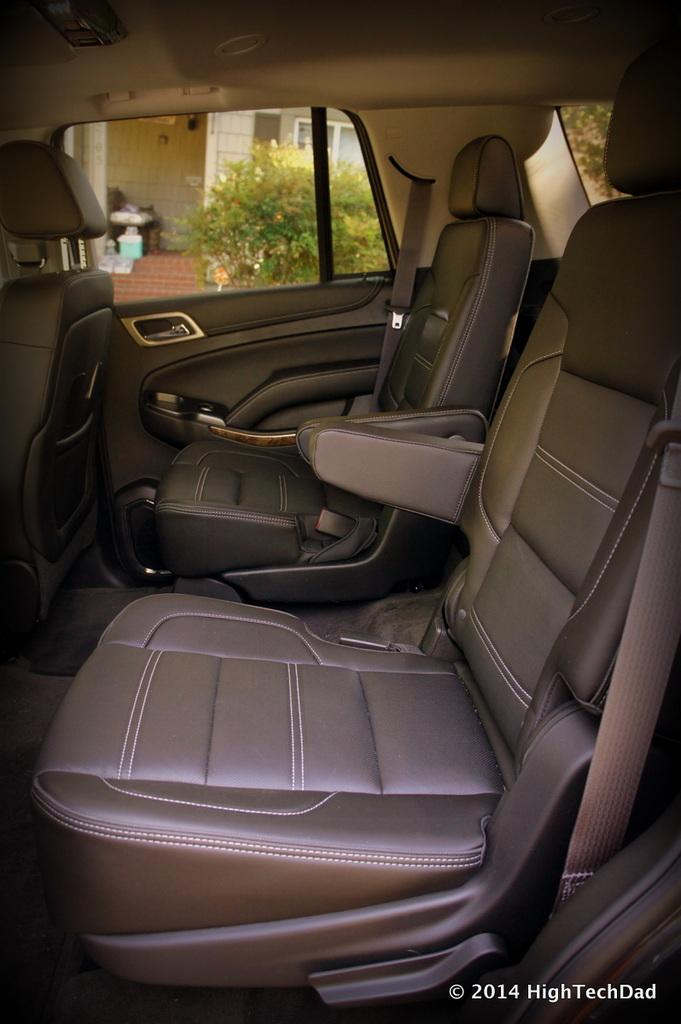What type of vehicle is shown in the image? There is an inner view of a car in the image. What part of the car is visible in the image? There is a door visible in the image. What can be seen in the background of the image? There are plants on the backside of the image. What color is the zebra sitting in the car in the image? There is no zebra present in the image; it is an inner view of a car with a door visible. 